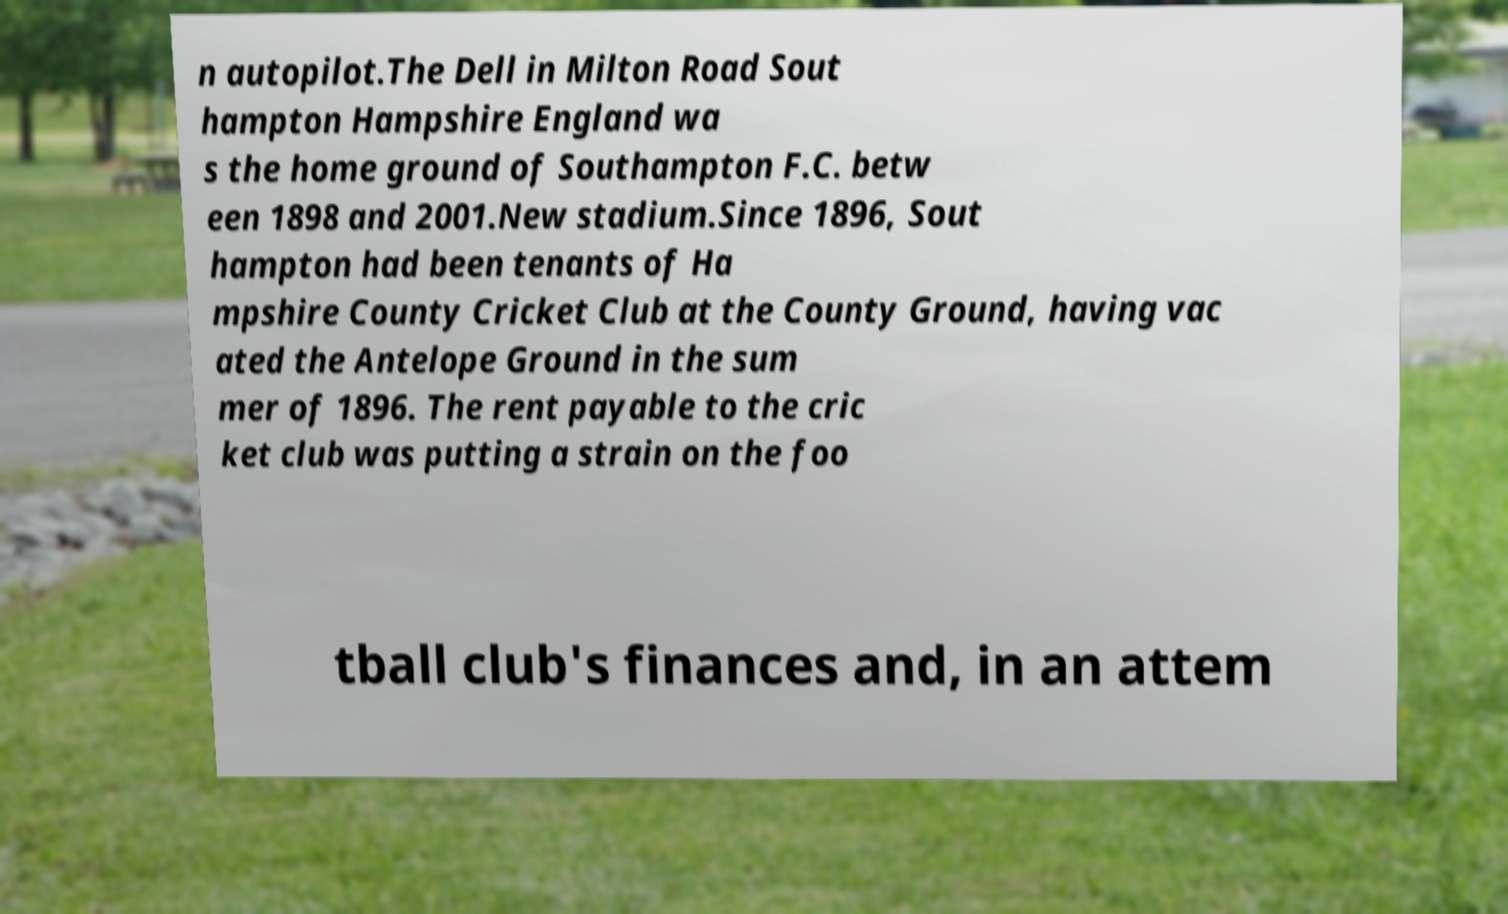What messages or text are displayed in this image? I need them in a readable, typed format. n autopilot.The Dell in Milton Road Sout hampton Hampshire England wa s the home ground of Southampton F.C. betw een 1898 and 2001.New stadium.Since 1896, Sout hampton had been tenants of Ha mpshire County Cricket Club at the County Ground, having vac ated the Antelope Ground in the sum mer of 1896. The rent payable to the cric ket club was putting a strain on the foo tball club's finances and, in an attem 